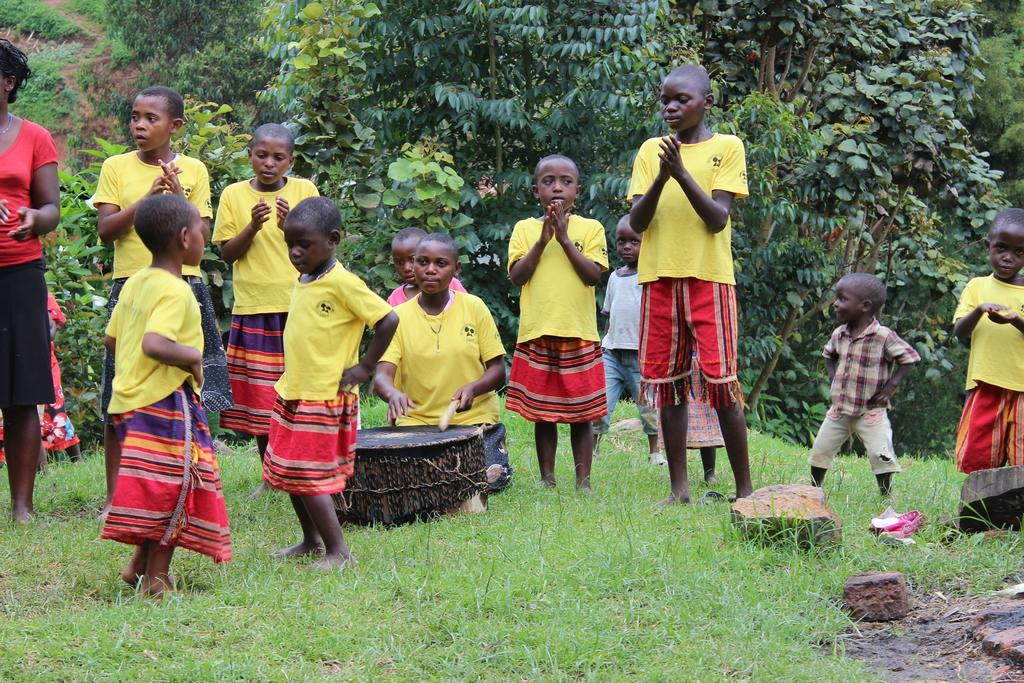What is the main subject of the image? The main subject of the image is children. Where are the children located in the image? The children are in the center of the image. What can be seen in the background of the image? There are trees in the background of the image. What type of ground is visible at the bottom of the image? There is grass at the bottom of the image. How many cattle are present in the image? There are no cattle present in the image. What type of account does the representative in the image hold? There is no representative or account mentioned in the image. 